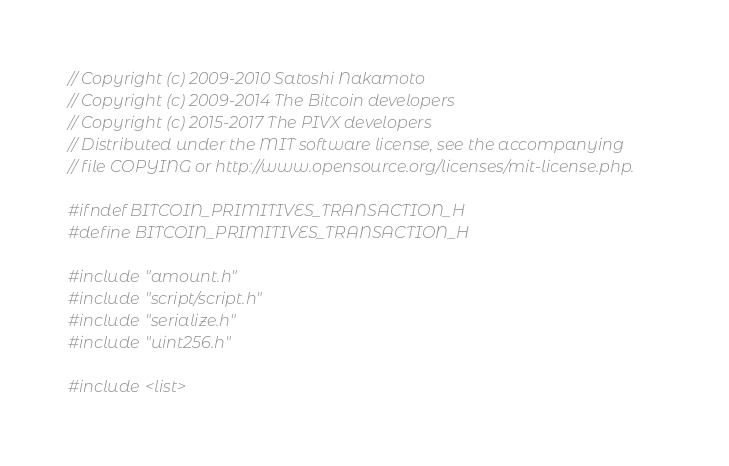<code> <loc_0><loc_0><loc_500><loc_500><_C_>// Copyright (c) 2009-2010 Satoshi Nakamoto
// Copyright (c) 2009-2014 The Bitcoin developers
// Copyright (c) 2015-2017 The PIVX developers
// Distributed under the MIT software license, see the accompanying
// file COPYING or http://www.opensource.org/licenses/mit-license.php.

#ifndef BITCOIN_PRIMITIVES_TRANSACTION_H
#define BITCOIN_PRIMITIVES_TRANSACTION_H

#include "amount.h"
#include "script/script.h"
#include "serialize.h"
#include "uint256.h"

#include <list>
</code> 